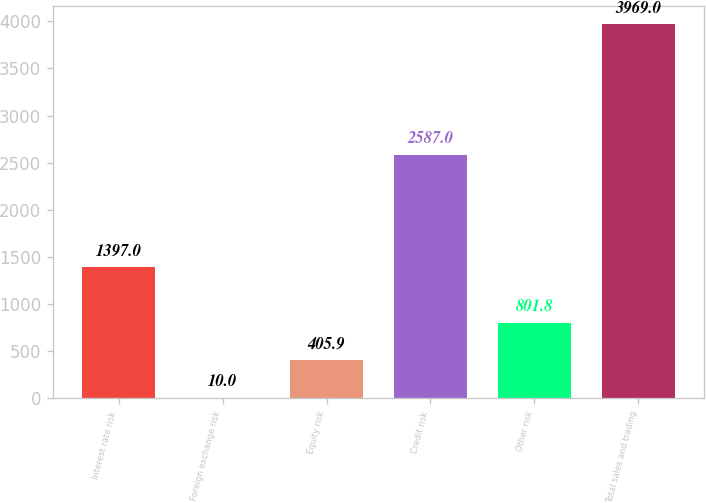<chart> <loc_0><loc_0><loc_500><loc_500><bar_chart><fcel>Interest rate risk<fcel>Foreign exchange risk<fcel>Equity risk<fcel>Credit risk<fcel>Other risk<fcel>Total sales and trading<nl><fcel>1397<fcel>10<fcel>405.9<fcel>2587<fcel>801.8<fcel>3969<nl></chart> 